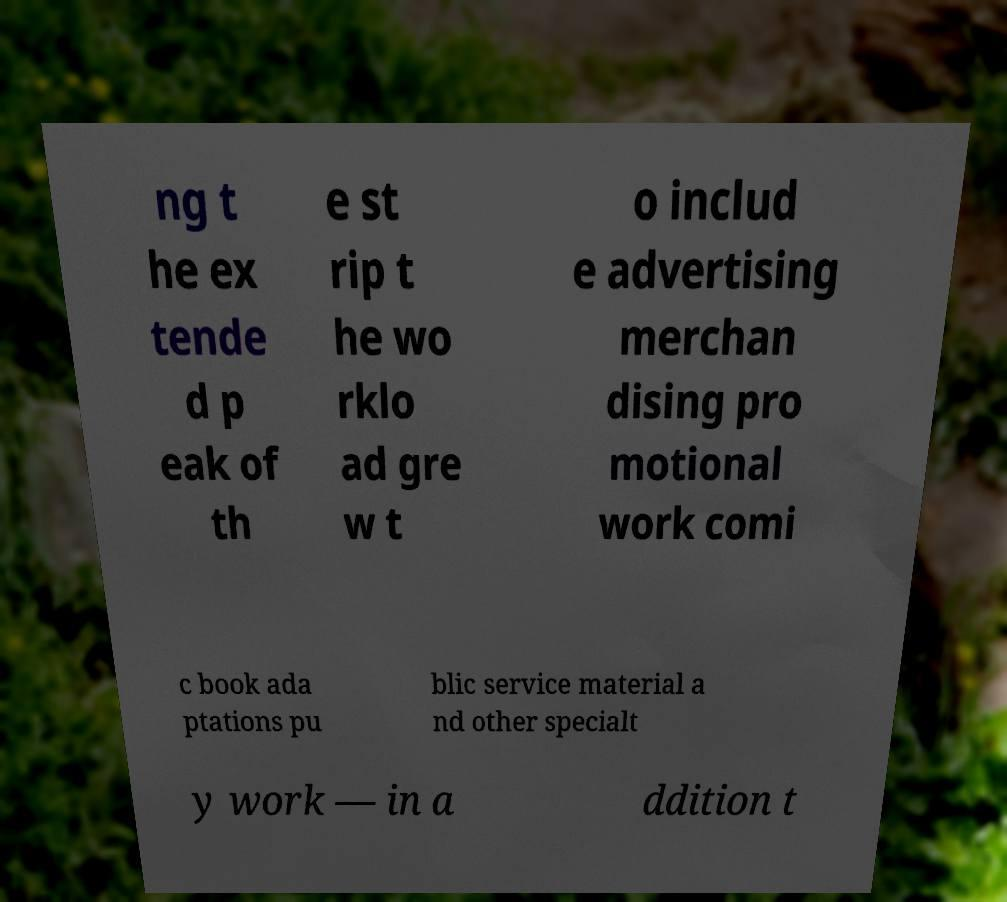Could you assist in decoding the text presented in this image and type it out clearly? ng t he ex tende d p eak of th e st rip t he wo rklo ad gre w t o includ e advertising merchan dising pro motional work comi c book ada ptations pu blic service material a nd other specialt y work — in a ddition t 